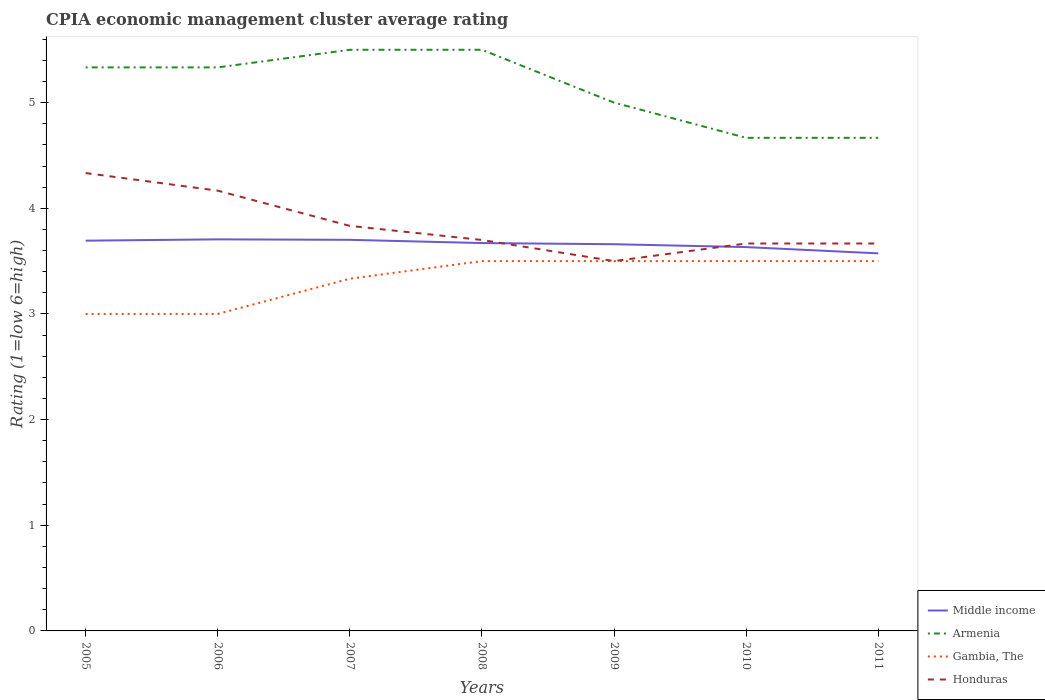How many different coloured lines are there?
Provide a succinct answer. 4. Across all years, what is the maximum CPIA rating in Gambia, The?
Give a very brief answer. 3. In which year was the CPIA rating in Honduras maximum?
Your response must be concise. 2009. What is the total CPIA rating in Armenia in the graph?
Make the answer very short. -0.17. What is the difference between the highest and the second highest CPIA rating in Honduras?
Your answer should be very brief. 0.83. Is the CPIA rating in Armenia strictly greater than the CPIA rating in Middle income over the years?
Offer a very short reply. No. How many years are there in the graph?
Ensure brevity in your answer.  7. Where does the legend appear in the graph?
Your response must be concise. Bottom right. How are the legend labels stacked?
Provide a short and direct response. Vertical. What is the title of the graph?
Provide a short and direct response. CPIA economic management cluster average rating. Does "Italy" appear as one of the legend labels in the graph?
Offer a very short reply. No. What is the Rating (1=low 6=high) in Middle income in 2005?
Provide a short and direct response. 3.69. What is the Rating (1=low 6=high) in Armenia in 2005?
Offer a terse response. 5.33. What is the Rating (1=low 6=high) of Honduras in 2005?
Offer a very short reply. 4.33. What is the Rating (1=low 6=high) of Middle income in 2006?
Provide a short and direct response. 3.71. What is the Rating (1=low 6=high) of Armenia in 2006?
Ensure brevity in your answer.  5.33. What is the Rating (1=low 6=high) in Gambia, The in 2006?
Provide a short and direct response. 3. What is the Rating (1=low 6=high) of Honduras in 2006?
Offer a terse response. 4.17. What is the Rating (1=low 6=high) in Middle income in 2007?
Your answer should be compact. 3.7. What is the Rating (1=low 6=high) of Gambia, The in 2007?
Your response must be concise. 3.33. What is the Rating (1=low 6=high) of Honduras in 2007?
Your answer should be compact. 3.83. What is the Rating (1=low 6=high) in Middle income in 2008?
Offer a very short reply. 3.67. What is the Rating (1=low 6=high) of Armenia in 2008?
Your answer should be very brief. 5.5. What is the Rating (1=low 6=high) of Gambia, The in 2008?
Offer a terse response. 3.5. What is the Rating (1=low 6=high) in Honduras in 2008?
Your answer should be very brief. 3.7. What is the Rating (1=low 6=high) of Middle income in 2009?
Make the answer very short. 3.66. What is the Rating (1=low 6=high) of Armenia in 2009?
Your response must be concise. 5. What is the Rating (1=low 6=high) in Gambia, The in 2009?
Give a very brief answer. 3.5. What is the Rating (1=low 6=high) in Middle income in 2010?
Offer a terse response. 3.63. What is the Rating (1=low 6=high) of Armenia in 2010?
Offer a very short reply. 4.67. What is the Rating (1=low 6=high) in Honduras in 2010?
Your answer should be compact. 3.67. What is the Rating (1=low 6=high) of Middle income in 2011?
Give a very brief answer. 3.57. What is the Rating (1=low 6=high) of Armenia in 2011?
Your answer should be compact. 4.67. What is the Rating (1=low 6=high) in Gambia, The in 2011?
Ensure brevity in your answer.  3.5. What is the Rating (1=low 6=high) of Honduras in 2011?
Offer a very short reply. 3.67. Across all years, what is the maximum Rating (1=low 6=high) of Middle income?
Offer a terse response. 3.71. Across all years, what is the maximum Rating (1=low 6=high) of Armenia?
Ensure brevity in your answer.  5.5. Across all years, what is the maximum Rating (1=low 6=high) in Honduras?
Give a very brief answer. 4.33. Across all years, what is the minimum Rating (1=low 6=high) of Middle income?
Provide a succinct answer. 3.57. Across all years, what is the minimum Rating (1=low 6=high) of Armenia?
Give a very brief answer. 4.67. Across all years, what is the minimum Rating (1=low 6=high) of Honduras?
Your answer should be very brief. 3.5. What is the total Rating (1=low 6=high) of Middle income in the graph?
Provide a succinct answer. 25.64. What is the total Rating (1=low 6=high) of Armenia in the graph?
Give a very brief answer. 36. What is the total Rating (1=low 6=high) in Gambia, The in the graph?
Offer a terse response. 23.33. What is the total Rating (1=low 6=high) in Honduras in the graph?
Make the answer very short. 26.87. What is the difference between the Rating (1=low 6=high) in Middle income in 2005 and that in 2006?
Provide a succinct answer. -0.01. What is the difference between the Rating (1=low 6=high) in Armenia in 2005 and that in 2006?
Provide a short and direct response. 0. What is the difference between the Rating (1=low 6=high) of Middle income in 2005 and that in 2007?
Give a very brief answer. -0.01. What is the difference between the Rating (1=low 6=high) in Armenia in 2005 and that in 2007?
Give a very brief answer. -0.17. What is the difference between the Rating (1=low 6=high) of Gambia, The in 2005 and that in 2007?
Your response must be concise. -0.33. What is the difference between the Rating (1=low 6=high) in Middle income in 2005 and that in 2008?
Offer a terse response. 0.02. What is the difference between the Rating (1=low 6=high) of Armenia in 2005 and that in 2008?
Offer a very short reply. -0.17. What is the difference between the Rating (1=low 6=high) of Honduras in 2005 and that in 2008?
Provide a succinct answer. 0.63. What is the difference between the Rating (1=low 6=high) of Middle income in 2005 and that in 2009?
Offer a terse response. 0.03. What is the difference between the Rating (1=low 6=high) in Gambia, The in 2005 and that in 2009?
Make the answer very short. -0.5. What is the difference between the Rating (1=low 6=high) in Honduras in 2005 and that in 2009?
Your answer should be very brief. 0.83. What is the difference between the Rating (1=low 6=high) in Middle income in 2005 and that in 2010?
Your response must be concise. 0.06. What is the difference between the Rating (1=low 6=high) in Armenia in 2005 and that in 2010?
Provide a succinct answer. 0.67. What is the difference between the Rating (1=low 6=high) of Gambia, The in 2005 and that in 2010?
Your answer should be compact. -0.5. What is the difference between the Rating (1=low 6=high) of Honduras in 2005 and that in 2010?
Keep it short and to the point. 0.67. What is the difference between the Rating (1=low 6=high) in Middle income in 2005 and that in 2011?
Ensure brevity in your answer.  0.12. What is the difference between the Rating (1=low 6=high) in Armenia in 2005 and that in 2011?
Your answer should be compact. 0.67. What is the difference between the Rating (1=low 6=high) of Gambia, The in 2005 and that in 2011?
Your answer should be compact. -0.5. What is the difference between the Rating (1=low 6=high) of Honduras in 2005 and that in 2011?
Keep it short and to the point. 0.67. What is the difference between the Rating (1=low 6=high) in Middle income in 2006 and that in 2007?
Offer a very short reply. 0. What is the difference between the Rating (1=low 6=high) of Armenia in 2006 and that in 2007?
Provide a succinct answer. -0.17. What is the difference between the Rating (1=low 6=high) in Honduras in 2006 and that in 2007?
Your response must be concise. 0.33. What is the difference between the Rating (1=low 6=high) in Middle income in 2006 and that in 2008?
Ensure brevity in your answer.  0.04. What is the difference between the Rating (1=low 6=high) in Gambia, The in 2006 and that in 2008?
Provide a short and direct response. -0.5. What is the difference between the Rating (1=low 6=high) in Honduras in 2006 and that in 2008?
Make the answer very short. 0.47. What is the difference between the Rating (1=low 6=high) in Middle income in 2006 and that in 2009?
Offer a very short reply. 0.05. What is the difference between the Rating (1=low 6=high) of Gambia, The in 2006 and that in 2009?
Offer a terse response. -0.5. What is the difference between the Rating (1=low 6=high) of Honduras in 2006 and that in 2009?
Make the answer very short. 0.67. What is the difference between the Rating (1=low 6=high) in Middle income in 2006 and that in 2010?
Provide a short and direct response. 0.07. What is the difference between the Rating (1=low 6=high) of Armenia in 2006 and that in 2010?
Your answer should be compact. 0.67. What is the difference between the Rating (1=low 6=high) in Middle income in 2006 and that in 2011?
Offer a very short reply. 0.13. What is the difference between the Rating (1=low 6=high) of Middle income in 2007 and that in 2008?
Ensure brevity in your answer.  0.03. What is the difference between the Rating (1=low 6=high) in Armenia in 2007 and that in 2008?
Provide a short and direct response. 0. What is the difference between the Rating (1=low 6=high) of Gambia, The in 2007 and that in 2008?
Your answer should be compact. -0.17. What is the difference between the Rating (1=low 6=high) of Honduras in 2007 and that in 2008?
Your response must be concise. 0.13. What is the difference between the Rating (1=low 6=high) in Middle income in 2007 and that in 2009?
Your answer should be very brief. 0.04. What is the difference between the Rating (1=low 6=high) in Armenia in 2007 and that in 2009?
Keep it short and to the point. 0.5. What is the difference between the Rating (1=low 6=high) in Honduras in 2007 and that in 2009?
Make the answer very short. 0.33. What is the difference between the Rating (1=low 6=high) in Middle income in 2007 and that in 2010?
Provide a short and direct response. 0.07. What is the difference between the Rating (1=low 6=high) in Armenia in 2007 and that in 2010?
Your response must be concise. 0.83. What is the difference between the Rating (1=low 6=high) in Middle income in 2007 and that in 2011?
Your answer should be compact. 0.13. What is the difference between the Rating (1=low 6=high) in Middle income in 2008 and that in 2009?
Make the answer very short. 0.01. What is the difference between the Rating (1=low 6=high) of Honduras in 2008 and that in 2009?
Make the answer very short. 0.2. What is the difference between the Rating (1=low 6=high) of Middle income in 2008 and that in 2010?
Make the answer very short. 0.04. What is the difference between the Rating (1=low 6=high) of Armenia in 2008 and that in 2010?
Provide a short and direct response. 0.83. What is the difference between the Rating (1=low 6=high) of Gambia, The in 2008 and that in 2010?
Ensure brevity in your answer.  0. What is the difference between the Rating (1=low 6=high) in Honduras in 2008 and that in 2010?
Your answer should be compact. 0.03. What is the difference between the Rating (1=low 6=high) of Middle income in 2008 and that in 2011?
Offer a terse response. 0.1. What is the difference between the Rating (1=low 6=high) of Honduras in 2008 and that in 2011?
Provide a short and direct response. 0.03. What is the difference between the Rating (1=low 6=high) of Middle income in 2009 and that in 2010?
Ensure brevity in your answer.  0.03. What is the difference between the Rating (1=low 6=high) of Armenia in 2009 and that in 2010?
Make the answer very short. 0.33. What is the difference between the Rating (1=low 6=high) in Gambia, The in 2009 and that in 2010?
Keep it short and to the point. 0. What is the difference between the Rating (1=low 6=high) of Honduras in 2009 and that in 2010?
Offer a very short reply. -0.17. What is the difference between the Rating (1=low 6=high) of Middle income in 2009 and that in 2011?
Offer a terse response. 0.09. What is the difference between the Rating (1=low 6=high) in Armenia in 2009 and that in 2011?
Keep it short and to the point. 0.33. What is the difference between the Rating (1=low 6=high) of Middle income in 2010 and that in 2011?
Your response must be concise. 0.06. What is the difference between the Rating (1=low 6=high) in Gambia, The in 2010 and that in 2011?
Your answer should be very brief. 0. What is the difference between the Rating (1=low 6=high) in Middle income in 2005 and the Rating (1=low 6=high) in Armenia in 2006?
Your response must be concise. -1.64. What is the difference between the Rating (1=low 6=high) in Middle income in 2005 and the Rating (1=low 6=high) in Gambia, The in 2006?
Your response must be concise. 0.69. What is the difference between the Rating (1=low 6=high) of Middle income in 2005 and the Rating (1=low 6=high) of Honduras in 2006?
Your response must be concise. -0.47. What is the difference between the Rating (1=low 6=high) of Armenia in 2005 and the Rating (1=low 6=high) of Gambia, The in 2006?
Ensure brevity in your answer.  2.33. What is the difference between the Rating (1=low 6=high) of Armenia in 2005 and the Rating (1=low 6=high) of Honduras in 2006?
Offer a terse response. 1.17. What is the difference between the Rating (1=low 6=high) in Gambia, The in 2005 and the Rating (1=low 6=high) in Honduras in 2006?
Offer a terse response. -1.17. What is the difference between the Rating (1=low 6=high) of Middle income in 2005 and the Rating (1=low 6=high) of Armenia in 2007?
Provide a succinct answer. -1.81. What is the difference between the Rating (1=low 6=high) of Middle income in 2005 and the Rating (1=low 6=high) of Gambia, The in 2007?
Ensure brevity in your answer.  0.36. What is the difference between the Rating (1=low 6=high) in Middle income in 2005 and the Rating (1=low 6=high) in Honduras in 2007?
Your answer should be very brief. -0.14. What is the difference between the Rating (1=low 6=high) in Armenia in 2005 and the Rating (1=low 6=high) in Gambia, The in 2007?
Offer a terse response. 2. What is the difference between the Rating (1=low 6=high) of Middle income in 2005 and the Rating (1=low 6=high) of Armenia in 2008?
Give a very brief answer. -1.81. What is the difference between the Rating (1=low 6=high) in Middle income in 2005 and the Rating (1=low 6=high) in Gambia, The in 2008?
Your answer should be very brief. 0.19. What is the difference between the Rating (1=low 6=high) in Middle income in 2005 and the Rating (1=low 6=high) in Honduras in 2008?
Your response must be concise. -0.01. What is the difference between the Rating (1=low 6=high) in Armenia in 2005 and the Rating (1=low 6=high) in Gambia, The in 2008?
Your answer should be very brief. 1.83. What is the difference between the Rating (1=low 6=high) of Armenia in 2005 and the Rating (1=low 6=high) of Honduras in 2008?
Ensure brevity in your answer.  1.63. What is the difference between the Rating (1=low 6=high) of Gambia, The in 2005 and the Rating (1=low 6=high) of Honduras in 2008?
Provide a succinct answer. -0.7. What is the difference between the Rating (1=low 6=high) of Middle income in 2005 and the Rating (1=low 6=high) of Armenia in 2009?
Make the answer very short. -1.31. What is the difference between the Rating (1=low 6=high) of Middle income in 2005 and the Rating (1=low 6=high) of Gambia, The in 2009?
Your answer should be very brief. 0.19. What is the difference between the Rating (1=low 6=high) in Middle income in 2005 and the Rating (1=low 6=high) in Honduras in 2009?
Your response must be concise. 0.19. What is the difference between the Rating (1=low 6=high) in Armenia in 2005 and the Rating (1=low 6=high) in Gambia, The in 2009?
Your answer should be very brief. 1.83. What is the difference between the Rating (1=low 6=high) in Armenia in 2005 and the Rating (1=low 6=high) in Honduras in 2009?
Your response must be concise. 1.83. What is the difference between the Rating (1=low 6=high) in Middle income in 2005 and the Rating (1=low 6=high) in Armenia in 2010?
Keep it short and to the point. -0.97. What is the difference between the Rating (1=low 6=high) of Middle income in 2005 and the Rating (1=low 6=high) of Gambia, The in 2010?
Make the answer very short. 0.19. What is the difference between the Rating (1=low 6=high) of Middle income in 2005 and the Rating (1=low 6=high) of Honduras in 2010?
Ensure brevity in your answer.  0.03. What is the difference between the Rating (1=low 6=high) of Armenia in 2005 and the Rating (1=low 6=high) of Gambia, The in 2010?
Ensure brevity in your answer.  1.83. What is the difference between the Rating (1=low 6=high) in Armenia in 2005 and the Rating (1=low 6=high) in Honduras in 2010?
Provide a short and direct response. 1.67. What is the difference between the Rating (1=low 6=high) of Middle income in 2005 and the Rating (1=low 6=high) of Armenia in 2011?
Your response must be concise. -0.97. What is the difference between the Rating (1=low 6=high) in Middle income in 2005 and the Rating (1=low 6=high) in Gambia, The in 2011?
Your answer should be very brief. 0.19. What is the difference between the Rating (1=low 6=high) in Middle income in 2005 and the Rating (1=low 6=high) in Honduras in 2011?
Offer a very short reply. 0.03. What is the difference between the Rating (1=low 6=high) of Armenia in 2005 and the Rating (1=low 6=high) of Gambia, The in 2011?
Keep it short and to the point. 1.83. What is the difference between the Rating (1=low 6=high) in Armenia in 2005 and the Rating (1=low 6=high) in Honduras in 2011?
Your response must be concise. 1.67. What is the difference between the Rating (1=low 6=high) in Middle income in 2006 and the Rating (1=low 6=high) in Armenia in 2007?
Your answer should be very brief. -1.79. What is the difference between the Rating (1=low 6=high) in Middle income in 2006 and the Rating (1=low 6=high) in Gambia, The in 2007?
Offer a terse response. 0.37. What is the difference between the Rating (1=low 6=high) of Middle income in 2006 and the Rating (1=low 6=high) of Honduras in 2007?
Ensure brevity in your answer.  -0.13. What is the difference between the Rating (1=low 6=high) of Gambia, The in 2006 and the Rating (1=low 6=high) of Honduras in 2007?
Your answer should be compact. -0.83. What is the difference between the Rating (1=low 6=high) in Middle income in 2006 and the Rating (1=low 6=high) in Armenia in 2008?
Keep it short and to the point. -1.79. What is the difference between the Rating (1=low 6=high) in Middle income in 2006 and the Rating (1=low 6=high) in Gambia, The in 2008?
Your answer should be very brief. 0.21. What is the difference between the Rating (1=low 6=high) of Middle income in 2006 and the Rating (1=low 6=high) of Honduras in 2008?
Give a very brief answer. 0.01. What is the difference between the Rating (1=low 6=high) of Armenia in 2006 and the Rating (1=low 6=high) of Gambia, The in 2008?
Ensure brevity in your answer.  1.83. What is the difference between the Rating (1=low 6=high) of Armenia in 2006 and the Rating (1=low 6=high) of Honduras in 2008?
Offer a very short reply. 1.63. What is the difference between the Rating (1=low 6=high) in Gambia, The in 2006 and the Rating (1=low 6=high) in Honduras in 2008?
Make the answer very short. -0.7. What is the difference between the Rating (1=low 6=high) in Middle income in 2006 and the Rating (1=low 6=high) in Armenia in 2009?
Your answer should be compact. -1.29. What is the difference between the Rating (1=low 6=high) in Middle income in 2006 and the Rating (1=low 6=high) in Gambia, The in 2009?
Provide a succinct answer. 0.21. What is the difference between the Rating (1=low 6=high) in Middle income in 2006 and the Rating (1=low 6=high) in Honduras in 2009?
Ensure brevity in your answer.  0.21. What is the difference between the Rating (1=low 6=high) in Armenia in 2006 and the Rating (1=low 6=high) in Gambia, The in 2009?
Offer a very short reply. 1.83. What is the difference between the Rating (1=low 6=high) of Armenia in 2006 and the Rating (1=low 6=high) of Honduras in 2009?
Your response must be concise. 1.83. What is the difference between the Rating (1=low 6=high) in Middle income in 2006 and the Rating (1=low 6=high) in Armenia in 2010?
Offer a very short reply. -0.96. What is the difference between the Rating (1=low 6=high) of Middle income in 2006 and the Rating (1=low 6=high) of Gambia, The in 2010?
Make the answer very short. 0.21. What is the difference between the Rating (1=low 6=high) in Middle income in 2006 and the Rating (1=low 6=high) in Honduras in 2010?
Offer a very short reply. 0.04. What is the difference between the Rating (1=low 6=high) in Armenia in 2006 and the Rating (1=low 6=high) in Gambia, The in 2010?
Offer a terse response. 1.83. What is the difference between the Rating (1=low 6=high) in Armenia in 2006 and the Rating (1=low 6=high) in Honduras in 2010?
Provide a short and direct response. 1.67. What is the difference between the Rating (1=low 6=high) of Middle income in 2006 and the Rating (1=low 6=high) of Armenia in 2011?
Give a very brief answer. -0.96. What is the difference between the Rating (1=low 6=high) in Middle income in 2006 and the Rating (1=low 6=high) in Gambia, The in 2011?
Your answer should be very brief. 0.21. What is the difference between the Rating (1=low 6=high) in Middle income in 2006 and the Rating (1=low 6=high) in Honduras in 2011?
Give a very brief answer. 0.04. What is the difference between the Rating (1=low 6=high) of Armenia in 2006 and the Rating (1=low 6=high) of Gambia, The in 2011?
Provide a succinct answer. 1.83. What is the difference between the Rating (1=low 6=high) of Gambia, The in 2006 and the Rating (1=low 6=high) of Honduras in 2011?
Offer a terse response. -0.67. What is the difference between the Rating (1=low 6=high) in Middle income in 2007 and the Rating (1=low 6=high) in Armenia in 2008?
Provide a succinct answer. -1.8. What is the difference between the Rating (1=low 6=high) in Middle income in 2007 and the Rating (1=low 6=high) in Gambia, The in 2008?
Your answer should be very brief. 0.2. What is the difference between the Rating (1=low 6=high) of Middle income in 2007 and the Rating (1=low 6=high) of Honduras in 2008?
Make the answer very short. 0. What is the difference between the Rating (1=low 6=high) of Armenia in 2007 and the Rating (1=low 6=high) of Gambia, The in 2008?
Provide a short and direct response. 2. What is the difference between the Rating (1=low 6=high) of Armenia in 2007 and the Rating (1=low 6=high) of Honduras in 2008?
Give a very brief answer. 1.8. What is the difference between the Rating (1=low 6=high) of Gambia, The in 2007 and the Rating (1=low 6=high) of Honduras in 2008?
Give a very brief answer. -0.37. What is the difference between the Rating (1=low 6=high) in Middle income in 2007 and the Rating (1=low 6=high) in Armenia in 2009?
Offer a terse response. -1.3. What is the difference between the Rating (1=low 6=high) of Middle income in 2007 and the Rating (1=low 6=high) of Gambia, The in 2009?
Make the answer very short. 0.2. What is the difference between the Rating (1=low 6=high) in Middle income in 2007 and the Rating (1=low 6=high) in Honduras in 2009?
Ensure brevity in your answer.  0.2. What is the difference between the Rating (1=low 6=high) of Armenia in 2007 and the Rating (1=low 6=high) of Gambia, The in 2009?
Offer a very short reply. 2. What is the difference between the Rating (1=low 6=high) of Armenia in 2007 and the Rating (1=low 6=high) of Honduras in 2009?
Give a very brief answer. 2. What is the difference between the Rating (1=low 6=high) in Gambia, The in 2007 and the Rating (1=low 6=high) in Honduras in 2009?
Give a very brief answer. -0.17. What is the difference between the Rating (1=low 6=high) of Middle income in 2007 and the Rating (1=low 6=high) of Armenia in 2010?
Your answer should be very brief. -0.97. What is the difference between the Rating (1=low 6=high) in Middle income in 2007 and the Rating (1=low 6=high) in Gambia, The in 2010?
Your answer should be compact. 0.2. What is the difference between the Rating (1=low 6=high) in Middle income in 2007 and the Rating (1=low 6=high) in Honduras in 2010?
Keep it short and to the point. 0.03. What is the difference between the Rating (1=low 6=high) of Armenia in 2007 and the Rating (1=low 6=high) of Honduras in 2010?
Offer a very short reply. 1.83. What is the difference between the Rating (1=low 6=high) in Middle income in 2007 and the Rating (1=low 6=high) in Armenia in 2011?
Offer a terse response. -0.97. What is the difference between the Rating (1=low 6=high) of Middle income in 2007 and the Rating (1=low 6=high) of Gambia, The in 2011?
Provide a short and direct response. 0.2. What is the difference between the Rating (1=low 6=high) in Middle income in 2007 and the Rating (1=low 6=high) in Honduras in 2011?
Keep it short and to the point. 0.03. What is the difference between the Rating (1=low 6=high) of Armenia in 2007 and the Rating (1=low 6=high) of Honduras in 2011?
Ensure brevity in your answer.  1.83. What is the difference between the Rating (1=low 6=high) of Gambia, The in 2007 and the Rating (1=low 6=high) of Honduras in 2011?
Keep it short and to the point. -0.33. What is the difference between the Rating (1=low 6=high) of Middle income in 2008 and the Rating (1=low 6=high) of Armenia in 2009?
Give a very brief answer. -1.33. What is the difference between the Rating (1=low 6=high) in Middle income in 2008 and the Rating (1=low 6=high) in Gambia, The in 2009?
Ensure brevity in your answer.  0.17. What is the difference between the Rating (1=low 6=high) in Middle income in 2008 and the Rating (1=low 6=high) in Honduras in 2009?
Make the answer very short. 0.17. What is the difference between the Rating (1=low 6=high) in Armenia in 2008 and the Rating (1=low 6=high) in Gambia, The in 2009?
Offer a very short reply. 2. What is the difference between the Rating (1=low 6=high) of Armenia in 2008 and the Rating (1=low 6=high) of Honduras in 2009?
Your response must be concise. 2. What is the difference between the Rating (1=low 6=high) in Gambia, The in 2008 and the Rating (1=low 6=high) in Honduras in 2009?
Your answer should be compact. 0. What is the difference between the Rating (1=low 6=high) in Middle income in 2008 and the Rating (1=low 6=high) in Armenia in 2010?
Give a very brief answer. -1. What is the difference between the Rating (1=low 6=high) in Middle income in 2008 and the Rating (1=low 6=high) in Gambia, The in 2010?
Keep it short and to the point. 0.17. What is the difference between the Rating (1=low 6=high) in Middle income in 2008 and the Rating (1=low 6=high) in Honduras in 2010?
Your response must be concise. 0. What is the difference between the Rating (1=low 6=high) in Armenia in 2008 and the Rating (1=low 6=high) in Gambia, The in 2010?
Offer a terse response. 2. What is the difference between the Rating (1=low 6=high) in Armenia in 2008 and the Rating (1=low 6=high) in Honduras in 2010?
Your answer should be compact. 1.83. What is the difference between the Rating (1=low 6=high) in Gambia, The in 2008 and the Rating (1=low 6=high) in Honduras in 2010?
Offer a terse response. -0.17. What is the difference between the Rating (1=low 6=high) of Middle income in 2008 and the Rating (1=low 6=high) of Armenia in 2011?
Your answer should be compact. -1. What is the difference between the Rating (1=low 6=high) in Middle income in 2008 and the Rating (1=low 6=high) in Gambia, The in 2011?
Make the answer very short. 0.17. What is the difference between the Rating (1=low 6=high) of Middle income in 2008 and the Rating (1=low 6=high) of Honduras in 2011?
Give a very brief answer. 0. What is the difference between the Rating (1=low 6=high) in Armenia in 2008 and the Rating (1=low 6=high) in Gambia, The in 2011?
Your answer should be very brief. 2. What is the difference between the Rating (1=low 6=high) in Armenia in 2008 and the Rating (1=low 6=high) in Honduras in 2011?
Your answer should be compact. 1.83. What is the difference between the Rating (1=low 6=high) in Middle income in 2009 and the Rating (1=low 6=high) in Armenia in 2010?
Make the answer very short. -1.01. What is the difference between the Rating (1=low 6=high) in Middle income in 2009 and the Rating (1=low 6=high) in Gambia, The in 2010?
Offer a very short reply. 0.16. What is the difference between the Rating (1=low 6=high) in Middle income in 2009 and the Rating (1=low 6=high) in Honduras in 2010?
Give a very brief answer. -0.01. What is the difference between the Rating (1=low 6=high) in Armenia in 2009 and the Rating (1=low 6=high) in Gambia, The in 2010?
Offer a very short reply. 1.5. What is the difference between the Rating (1=low 6=high) of Armenia in 2009 and the Rating (1=low 6=high) of Honduras in 2010?
Your answer should be compact. 1.33. What is the difference between the Rating (1=low 6=high) in Middle income in 2009 and the Rating (1=low 6=high) in Armenia in 2011?
Keep it short and to the point. -1.01. What is the difference between the Rating (1=low 6=high) of Middle income in 2009 and the Rating (1=low 6=high) of Gambia, The in 2011?
Your answer should be very brief. 0.16. What is the difference between the Rating (1=low 6=high) of Middle income in 2009 and the Rating (1=low 6=high) of Honduras in 2011?
Keep it short and to the point. -0.01. What is the difference between the Rating (1=low 6=high) in Armenia in 2009 and the Rating (1=low 6=high) in Honduras in 2011?
Provide a short and direct response. 1.33. What is the difference between the Rating (1=low 6=high) in Middle income in 2010 and the Rating (1=low 6=high) in Armenia in 2011?
Ensure brevity in your answer.  -1.03. What is the difference between the Rating (1=low 6=high) in Middle income in 2010 and the Rating (1=low 6=high) in Gambia, The in 2011?
Give a very brief answer. 0.13. What is the difference between the Rating (1=low 6=high) in Middle income in 2010 and the Rating (1=low 6=high) in Honduras in 2011?
Your response must be concise. -0.03. What is the difference between the Rating (1=low 6=high) in Armenia in 2010 and the Rating (1=low 6=high) in Honduras in 2011?
Your answer should be compact. 1. What is the average Rating (1=low 6=high) in Middle income per year?
Your response must be concise. 3.66. What is the average Rating (1=low 6=high) in Armenia per year?
Your answer should be very brief. 5.14. What is the average Rating (1=low 6=high) of Gambia, The per year?
Your response must be concise. 3.33. What is the average Rating (1=low 6=high) of Honduras per year?
Give a very brief answer. 3.84. In the year 2005, what is the difference between the Rating (1=low 6=high) in Middle income and Rating (1=low 6=high) in Armenia?
Provide a succinct answer. -1.64. In the year 2005, what is the difference between the Rating (1=low 6=high) in Middle income and Rating (1=low 6=high) in Gambia, The?
Ensure brevity in your answer.  0.69. In the year 2005, what is the difference between the Rating (1=low 6=high) in Middle income and Rating (1=low 6=high) in Honduras?
Make the answer very short. -0.64. In the year 2005, what is the difference between the Rating (1=low 6=high) in Armenia and Rating (1=low 6=high) in Gambia, The?
Make the answer very short. 2.33. In the year 2005, what is the difference between the Rating (1=low 6=high) of Armenia and Rating (1=low 6=high) of Honduras?
Offer a very short reply. 1. In the year 2005, what is the difference between the Rating (1=low 6=high) of Gambia, The and Rating (1=low 6=high) of Honduras?
Your response must be concise. -1.33. In the year 2006, what is the difference between the Rating (1=low 6=high) of Middle income and Rating (1=low 6=high) of Armenia?
Ensure brevity in your answer.  -1.63. In the year 2006, what is the difference between the Rating (1=low 6=high) in Middle income and Rating (1=low 6=high) in Gambia, The?
Make the answer very short. 0.71. In the year 2006, what is the difference between the Rating (1=low 6=high) in Middle income and Rating (1=low 6=high) in Honduras?
Give a very brief answer. -0.46. In the year 2006, what is the difference between the Rating (1=low 6=high) of Armenia and Rating (1=low 6=high) of Gambia, The?
Offer a very short reply. 2.33. In the year 2006, what is the difference between the Rating (1=low 6=high) of Gambia, The and Rating (1=low 6=high) of Honduras?
Your response must be concise. -1.17. In the year 2007, what is the difference between the Rating (1=low 6=high) in Middle income and Rating (1=low 6=high) in Armenia?
Your answer should be compact. -1.8. In the year 2007, what is the difference between the Rating (1=low 6=high) of Middle income and Rating (1=low 6=high) of Gambia, The?
Give a very brief answer. 0.37. In the year 2007, what is the difference between the Rating (1=low 6=high) in Middle income and Rating (1=low 6=high) in Honduras?
Your answer should be compact. -0.13. In the year 2007, what is the difference between the Rating (1=low 6=high) of Armenia and Rating (1=low 6=high) of Gambia, The?
Your answer should be very brief. 2.17. In the year 2007, what is the difference between the Rating (1=low 6=high) of Armenia and Rating (1=low 6=high) of Honduras?
Offer a very short reply. 1.67. In the year 2008, what is the difference between the Rating (1=low 6=high) of Middle income and Rating (1=low 6=high) of Armenia?
Keep it short and to the point. -1.83. In the year 2008, what is the difference between the Rating (1=low 6=high) of Middle income and Rating (1=low 6=high) of Gambia, The?
Keep it short and to the point. 0.17. In the year 2008, what is the difference between the Rating (1=low 6=high) in Middle income and Rating (1=low 6=high) in Honduras?
Offer a terse response. -0.03. In the year 2008, what is the difference between the Rating (1=low 6=high) in Armenia and Rating (1=low 6=high) in Gambia, The?
Your answer should be very brief. 2. In the year 2008, what is the difference between the Rating (1=low 6=high) in Gambia, The and Rating (1=low 6=high) in Honduras?
Offer a very short reply. -0.2. In the year 2009, what is the difference between the Rating (1=low 6=high) of Middle income and Rating (1=low 6=high) of Armenia?
Your response must be concise. -1.34. In the year 2009, what is the difference between the Rating (1=low 6=high) in Middle income and Rating (1=low 6=high) in Gambia, The?
Give a very brief answer. 0.16. In the year 2009, what is the difference between the Rating (1=low 6=high) of Middle income and Rating (1=low 6=high) of Honduras?
Make the answer very short. 0.16. In the year 2010, what is the difference between the Rating (1=low 6=high) in Middle income and Rating (1=low 6=high) in Armenia?
Make the answer very short. -1.03. In the year 2010, what is the difference between the Rating (1=low 6=high) of Middle income and Rating (1=low 6=high) of Gambia, The?
Provide a succinct answer. 0.13. In the year 2010, what is the difference between the Rating (1=low 6=high) in Middle income and Rating (1=low 6=high) in Honduras?
Your response must be concise. -0.03. In the year 2010, what is the difference between the Rating (1=low 6=high) in Armenia and Rating (1=low 6=high) in Gambia, The?
Your answer should be very brief. 1.17. In the year 2010, what is the difference between the Rating (1=low 6=high) of Gambia, The and Rating (1=low 6=high) of Honduras?
Give a very brief answer. -0.17. In the year 2011, what is the difference between the Rating (1=low 6=high) in Middle income and Rating (1=low 6=high) in Armenia?
Your answer should be very brief. -1.09. In the year 2011, what is the difference between the Rating (1=low 6=high) in Middle income and Rating (1=low 6=high) in Gambia, The?
Ensure brevity in your answer.  0.07. In the year 2011, what is the difference between the Rating (1=low 6=high) of Middle income and Rating (1=low 6=high) of Honduras?
Give a very brief answer. -0.09. In the year 2011, what is the difference between the Rating (1=low 6=high) in Armenia and Rating (1=low 6=high) in Gambia, The?
Make the answer very short. 1.17. In the year 2011, what is the difference between the Rating (1=low 6=high) of Gambia, The and Rating (1=low 6=high) of Honduras?
Offer a very short reply. -0.17. What is the ratio of the Rating (1=low 6=high) in Middle income in 2005 to that in 2006?
Your response must be concise. 1. What is the ratio of the Rating (1=low 6=high) in Gambia, The in 2005 to that in 2006?
Your answer should be very brief. 1. What is the ratio of the Rating (1=low 6=high) of Honduras in 2005 to that in 2006?
Provide a succinct answer. 1.04. What is the ratio of the Rating (1=low 6=high) of Middle income in 2005 to that in 2007?
Your answer should be very brief. 1. What is the ratio of the Rating (1=low 6=high) of Armenia in 2005 to that in 2007?
Ensure brevity in your answer.  0.97. What is the ratio of the Rating (1=low 6=high) of Honduras in 2005 to that in 2007?
Ensure brevity in your answer.  1.13. What is the ratio of the Rating (1=low 6=high) in Middle income in 2005 to that in 2008?
Keep it short and to the point. 1.01. What is the ratio of the Rating (1=low 6=high) of Armenia in 2005 to that in 2008?
Provide a short and direct response. 0.97. What is the ratio of the Rating (1=low 6=high) of Gambia, The in 2005 to that in 2008?
Your answer should be compact. 0.86. What is the ratio of the Rating (1=low 6=high) of Honduras in 2005 to that in 2008?
Provide a succinct answer. 1.17. What is the ratio of the Rating (1=low 6=high) in Middle income in 2005 to that in 2009?
Keep it short and to the point. 1.01. What is the ratio of the Rating (1=low 6=high) of Armenia in 2005 to that in 2009?
Ensure brevity in your answer.  1.07. What is the ratio of the Rating (1=low 6=high) in Honduras in 2005 to that in 2009?
Your answer should be compact. 1.24. What is the ratio of the Rating (1=low 6=high) in Middle income in 2005 to that in 2010?
Keep it short and to the point. 1.02. What is the ratio of the Rating (1=low 6=high) in Honduras in 2005 to that in 2010?
Ensure brevity in your answer.  1.18. What is the ratio of the Rating (1=low 6=high) of Middle income in 2005 to that in 2011?
Provide a short and direct response. 1.03. What is the ratio of the Rating (1=low 6=high) of Armenia in 2005 to that in 2011?
Your response must be concise. 1.14. What is the ratio of the Rating (1=low 6=high) of Honduras in 2005 to that in 2011?
Offer a very short reply. 1.18. What is the ratio of the Rating (1=low 6=high) in Armenia in 2006 to that in 2007?
Your answer should be compact. 0.97. What is the ratio of the Rating (1=low 6=high) of Gambia, The in 2006 to that in 2007?
Provide a short and direct response. 0.9. What is the ratio of the Rating (1=low 6=high) in Honduras in 2006 to that in 2007?
Your answer should be very brief. 1.09. What is the ratio of the Rating (1=low 6=high) in Middle income in 2006 to that in 2008?
Your response must be concise. 1.01. What is the ratio of the Rating (1=low 6=high) of Armenia in 2006 to that in 2008?
Your answer should be compact. 0.97. What is the ratio of the Rating (1=low 6=high) in Honduras in 2006 to that in 2008?
Provide a succinct answer. 1.13. What is the ratio of the Rating (1=low 6=high) of Middle income in 2006 to that in 2009?
Provide a short and direct response. 1.01. What is the ratio of the Rating (1=low 6=high) in Armenia in 2006 to that in 2009?
Offer a terse response. 1.07. What is the ratio of the Rating (1=low 6=high) in Honduras in 2006 to that in 2009?
Your response must be concise. 1.19. What is the ratio of the Rating (1=low 6=high) of Middle income in 2006 to that in 2010?
Make the answer very short. 1.02. What is the ratio of the Rating (1=low 6=high) of Armenia in 2006 to that in 2010?
Ensure brevity in your answer.  1.14. What is the ratio of the Rating (1=low 6=high) in Gambia, The in 2006 to that in 2010?
Your answer should be compact. 0.86. What is the ratio of the Rating (1=low 6=high) of Honduras in 2006 to that in 2010?
Give a very brief answer. 1.14. What is the ratio of the Rating (1=low 6=high) of Middle income in 2006 to that in 2011?
Your answer should be very brief. 1.04. What is the ratio of the Rating (1=low 6=high) of Honduras in 2006 to that in 2011?
Your answer should be compact. 1.14. What is the ratio of the Rating (1=low 6=high) of Middle income in 2007 to that in 2008?
Offer a terse response. 1.01. What is the ratio of the Rating (1=low 6=high) of Gambia, The in 2007 to that in 2008?
Keep it short and to the point. 0.95. What is the ratio of the Rating (1=low 6=high) in Honduras in 2007 to that in 2008?
Keep it short and to the point. 1.04. What is the ratio of the Rating (1=low 6=high) in Middle income in 2007 to that in 2009?
Provide a short and direct response. 1.01. What is the ratio of the Rating (1=low 6=high) of Gambia, The in 2007 to that in 2009?
Give a very brief answer. 0.95. What is the ratio of the Rating (1=low 6=high) of Honduras in 2007 to that in 2009?
Keep it short and to the point. 1.1. What is the ratio of the Rating (1=low 6=high) in Middle income in 2007 to that in 2010?
Keep it short and to the point. 1.02. What is the ratio of the Rating (1=low 6=high) in Armenia in 2007 to that in 2010?
Your answer should be very brief. 1.18. What is the ratio of the Rating (1=low 6=high) of Honduras in 2007 to that in 2010?
Make the answer very short. 1.05. What is the ratio of the Rating (1=low 6=high) of Middle income in 2007 to that in 2011?
Offer a very short reply. 1.04. What is the ratio of the Rating (1=low 6=high) of Armenia in 2007 to that in 2011?
Give a very brief answer. 1.18. What is the ratio of the Rating (1=low 6=high) of Honduras in 2007 to that in 2011?
Provide a short and direct response. 1.05. What is the ratio of the Rating (1=low 6=high) of Middle income in 2008 to that in 2009?
Ensure brevity in your answer.  1. What is the ratio of the Rating (1=low 6=high) in Honduras in 2008 to that in 2009?
Give a very brief answer. 1.06. What is the ratio of the Rating (1=low 6=high) of Middle income in 2008 to that in 2010?
Provide a succinct answer. 1.01. What is the ratio of the Rating (1=low 6=high) in Armenia in 2008 to that in 2010?
Ensure brevity in your answer.  1.18. What is the ratio of the Rating (1=low 6=high) in Gambia, The in 2008 to that in 2010?
Offer a very short reply. 1. What is the ratio of the Rating (1=low 6=high) in Honduras in 2008 to that in 2010?
Ensure brevity in your answer.  1.01. What is the ratio of the Rating (1=low 6=high) in Middle income in 2008 to that in 2011?
Make the answer very short. 1.03. What is the ratio of the Rating (1=low 6=high) in Armenia in 2008 to that in 2011?
Make the answer very short. 1.18. What is the ratio of the Rating (1=low 6=high) of Gambia, The in 2008 to that in 2011?
Keep it short and to the point. 1. What is the ratio of the Rating (1=low 6=high) in Honduras in 2008 to that in 2011?
Offer a very short reply. 1.01. What is the ratio of the Rating (1=low 6=high) of Middle income in 2009 to that in 2010?
Keep it short and to the point. 1.01. What is the ratio of the Rating (1=low 6=high) in Armenia in 2009 to that in 2010?
Provide a succinct answer. 1.07. What is the ratio of the Rating (1=low 6=high) of Honduras in 2009 to that in 2010?
Give a very brief answer. 0.95. What is the ratio of the Rating (1=low 6=high) in Middle income in 2009 to that in 2011?
Your answer should be compact. 1.02. What is the ratio of the Rating (1=low 6=high) in Armenia in 2009 to that in 2011?
Provide a succinct answer. 1.07. What is the ratio of the Rating (1=low 6=high) in Gambia, The in 2009 to that in 2011?
Your answer should be very brief. 1. What is the ratio of the Rating (1=low 6=high) of Honduras in 2009 to that in 2011?
Your answer should be very brief. 0.95. What is the ratio of the Rating (1=low 6=high) of Middle income in 2010 to that in 2011?
Offer a terse response. 1.02. What is the ratio of the Rating (1=low 6=high) in Armenia in 2010 to that in 2011?
Keep it short and to the point. 1. What is the ratio of the Rating (1=low 6=high) of Honduras in 2010 to that in 2011?
Provide a succinct answer. 1. What is the difference between the highest and the second highest Rating (1=low 6=high) of Middle income?
Give a very brief answer. 0. What is the difference between the highest and the second highest Rating (1=low 6=high) of Armenia?
Your answer should be very brief. 0. What is the difference between the highest and the lowest Rating (1=low 6=high) in Middle income?
Your response must be concise. 0.13. What is the difference between the highest and the lowest Rating (1=low 6=high) in Gambia, The?
Your answer should be compact. 0.5. 